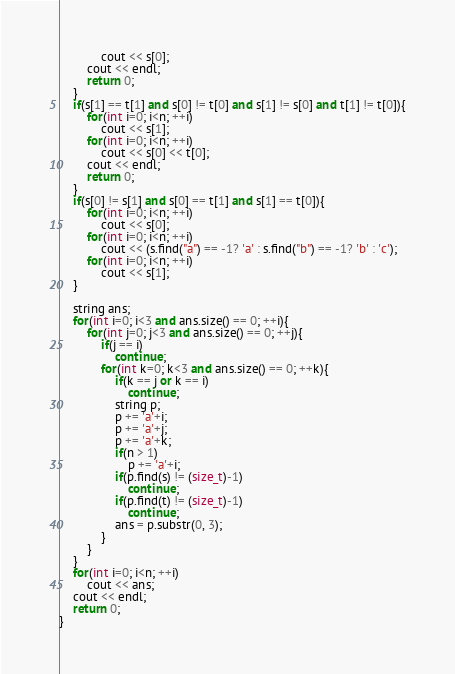Convert code to text. <code><loc_0><loc_0><loc_500><loc_500><_C++_>            cout << s[0];
        cout << endl;
        return 0;
    }
    if(s[1] == t[1] and s[0] != t[0] and s[1] != s[0] and t[1] != t[0]){
        for(int i=0; i<n; ++i)
            cout << s[1];
        for(int i=0; i<n; ++i)
            cout << s[0] << t[0];
        cout << endl;
        return 0;
    }
    if(s[0] != s[1] and s[0] == t[1] and s[1] == t[0]){
        for(int i=0; i<n; ++i)
            cout << s[0];
        for(int i=0; i<n; ++i)
            cout << (s.find("a") == -1? 'a' : s.find("b") == -1? 'b' : 'c');
        for(int i=0; i<n; ++i)
            cout << s[1];
    }

    string ans;
    for(int i=0; i<3 and ans.size() == 0; ++i){
        for(int j=0; j<3 and ans.size() == 0; ++j){
            if(j == i)
                continue;
            for(int k=0; k<3 and ans.size() == 0; ++k){
                if(k == j or k == i)
                    continue;
                string p;
                p += 'a'+i;
                p += 'a'+j;
                p += 'a'+k;
                if(n > 1)
                    p += 'a'+i;
                if(p.find(s) != (size_t)-1)
                    continue;
                if(p.find(t) != (size_t)-1)
                    continue;
                ans = p.substr(0, 3);
            }
        }
    }
    for(int i=0; i<n; ++i)
        cout << ans;
    cout << endl;
    return 0;
}
</code> 